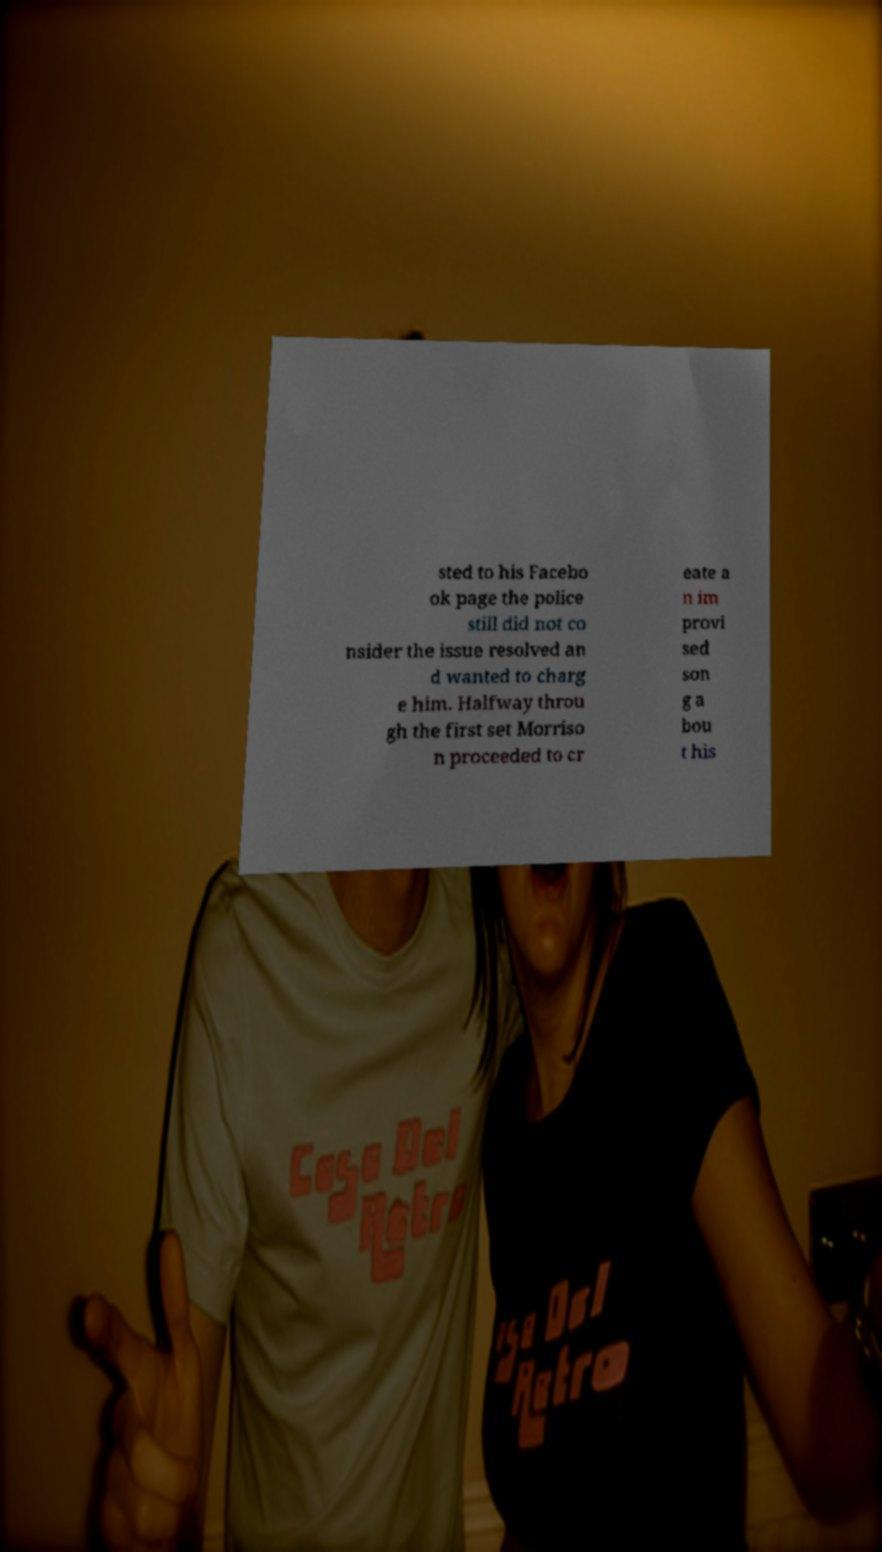Could you extract and type out the text from this image? sted to his Facebo ok page the police still did not co nsider the issue resolved an d wanted to charg e him. Halfway throu gh the first set Morriso n proceeded to cr eate a n im provi sed son g a bou t his 